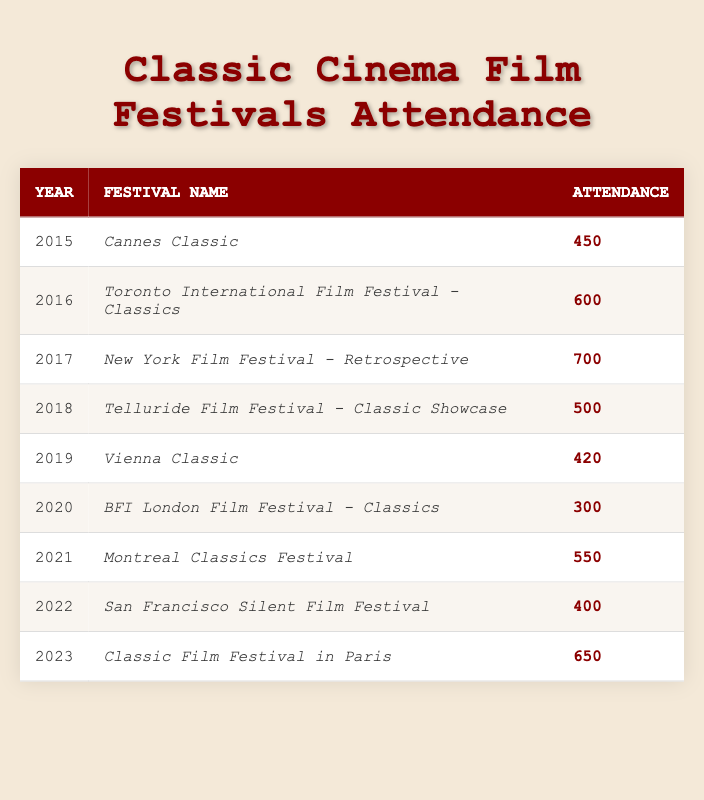What was the attendance at the New York Film Festival - Retrospective in 2017? The table shows that in 2017, the attendance at the New York Film Festival - Retrospective was 700.
Answer: 700 Which year had the highest attendance at a classic cinema film festival? By reviewing the attendance figures in the table, 2017 has the highest attendance of 700 at the New York Film Festival - Retrospective.
Answer: 2017 What is the average attendance across all the years listed in the table? To find the average attendance, sum the attendance values: (450 + 600 + 700 + 500 + 420 + 300 + 550 + 400 + 650) = 4270. There are 9 festivals, so the average is 4270/9 = approximately 474.44.
Answer: Approximately 474.44 Is the attendance at the Classic Film Festival in Paris higher than the average attendance of the film festivals? The attendance at the Classic Film Festival in Paris in 2023 is 650, and the average attendance is approximately 474.44. Since 650 is greater than 474.44, the statement is true.
Answer: Yes In which years did the attendance fall below 500? By examining the table, the years with attendance below 500 are 2015 (450), 2019 (420), and 2020 (300).
Answer: 2015, 2019, 2020 What is the difference in attendance between the highest and lowest festival attendance? The highest attendance is 700 (2017) and the lowest is 300 (2020). The difference is 700 - 300 = 400.
Answer: 400 Did the attendance at the Montreal Classics Festival in 2021 exceed that of the Telluride Film Festival in 2018? The attendance at the Montreal Classics Festival in 2021 is 550 and at the Telluride Film Festival in 2018 is 500. Since 550 is greater than 500, the statement is true.
Answer: Yes How many film festivals recorded an attendance under 500? By checking the table, the festivals that recorded an attendance under 500 are Cannes Classic (450), Vienna Classic (420), and BFI London Film Festival (300). That makes a total of 3 festivals.
Answer: 3 What festival had the second highest attendance, and what was its attendance? The second highest attendance is found by looking at the attendance values in descending order. The New York Film Festival - Retrospective had 700, followed by the Classic Film Festival in Paris in 2023 with 650.
Answer: Classic Film Festival in Paris, 650 